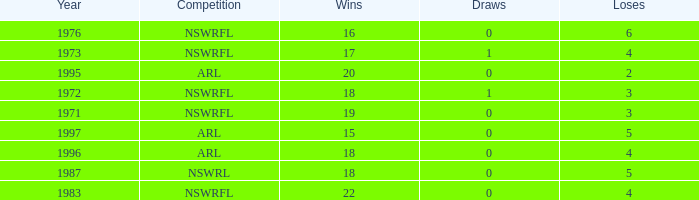What average Wins has Losses 2, and Draws less than 0? None. 